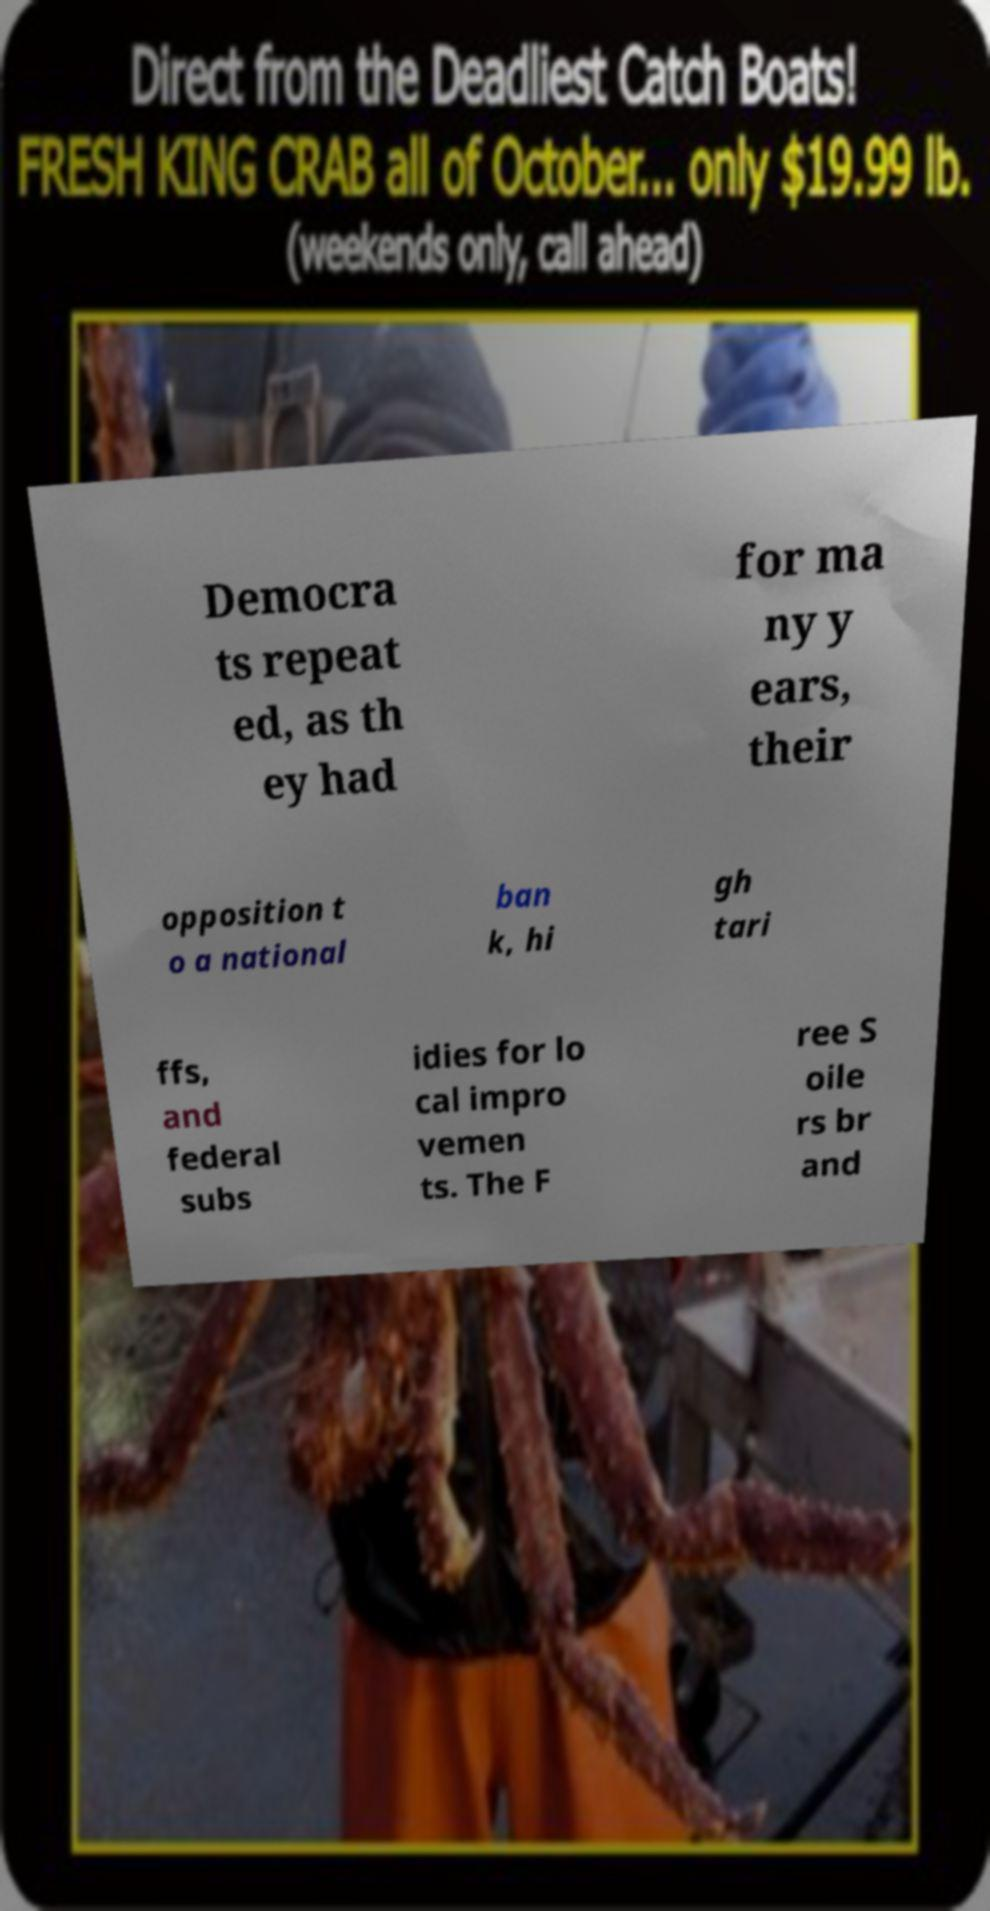For documentation purposes, I need the text within this image transcribed. Could you provide that? Democra ts repeat ed, as th ey had for ma ny y ears, their opposition t o a national ban k, hi gh tari ffs, and federal subs idies for lo cal impro vemen ts. The F ree S oile rs br and 